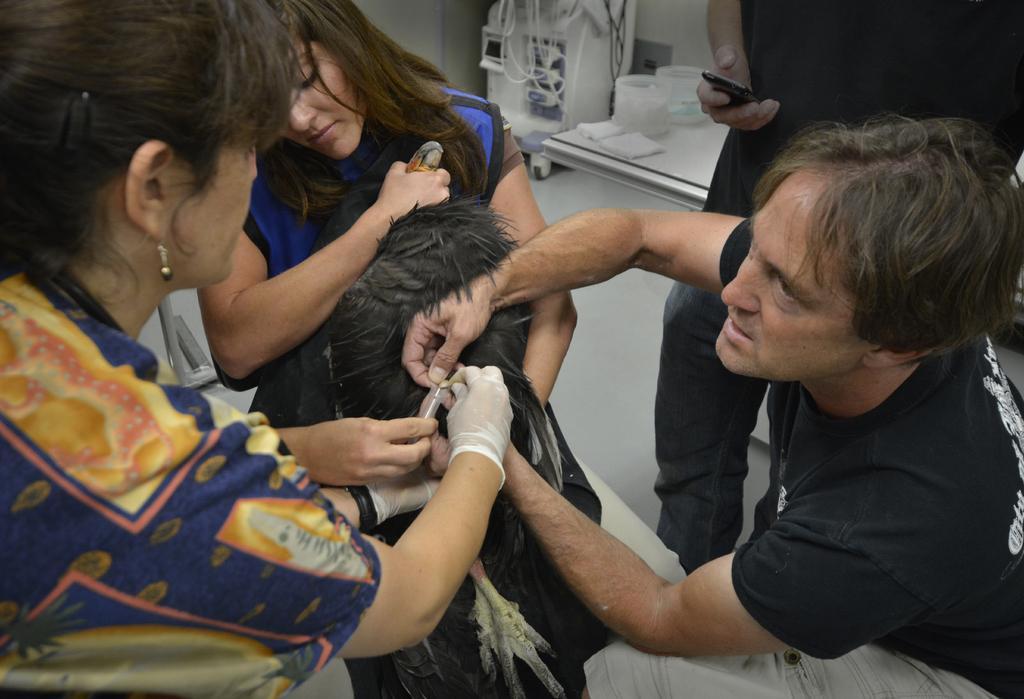Could you give a brief overview of what you see in this image? In this image we can see some people holding some objects and some people holding one bird. There is one objects on the surface, one wall, one machine on the surface and some objects are on the table. 